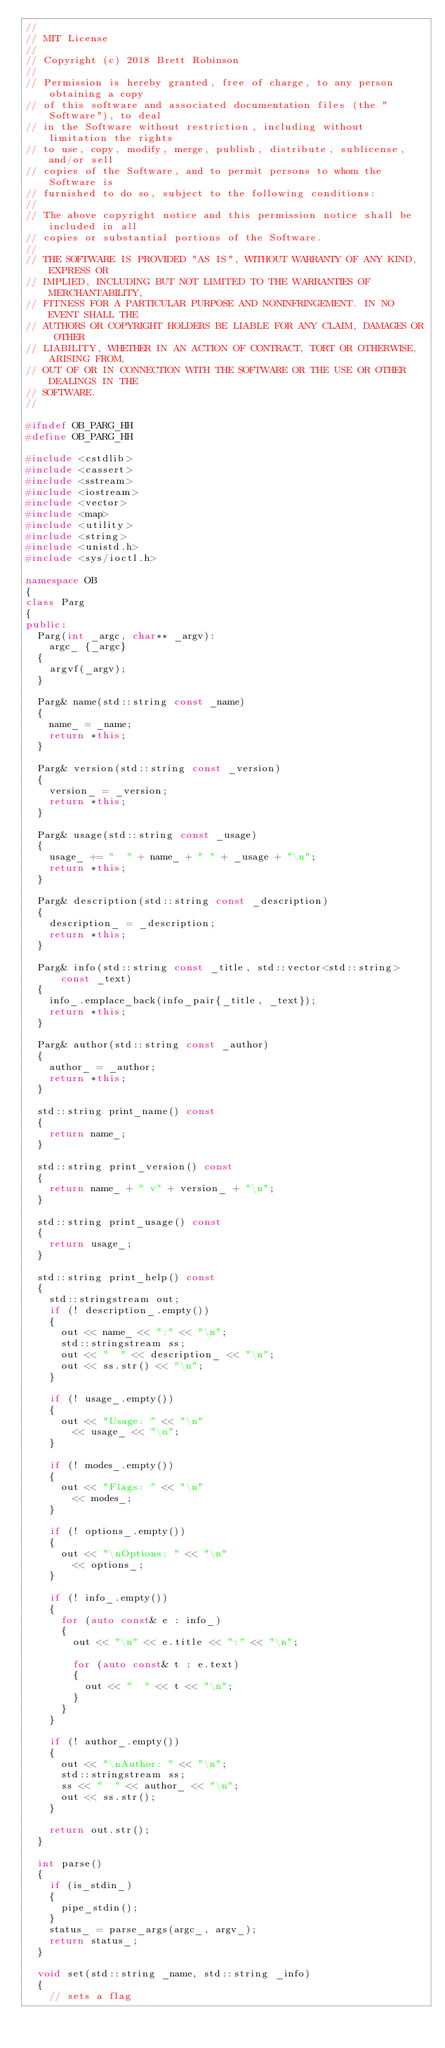<code> <loc_0><loc_0><loc_500><loc_500><_C++_>//
// MIT License
//
// Copyright (c) 2018 Brett Robinson
//
// Permission is hereby granted, free of charge, to any person obtaining a copy
// of this software and associated documentation files (the "Software"), to deal
// in the Software without restriction, including without limitation the rights
// to use, copy, modify, merge, publish, distribute, sublicense, and/or sell
// copies of the Software, and to permit persons to whom the Software is
// furnished to do so, subject to the following conditions:
//
// The above copyright notice and this permission notice shall be included in all
// copies or substantial portions of the Software.
//
// THE SOFTWARE IS PROVIDED "AS IS", WITHOUT WARRANTY OF ANY KIND, EXPRESS OR
// IMPLIED, INCLUDING BUT NOT LIMITED TO THE WARRANTIES OF MERCHANTABILITY,
// FITNESS FOR A PARTICULAR PURPOSE AND NONINFRINGEMENT. IN NO EVENT SHALL THE
// AUTHORS OR COPYRIGHT HOLDERS BE LIABLE FOR ANY CLAIM, DAMAGES OR OTHER
// LIABILITY, WHETHER IN AN ACTION OF CONTRACT, TORT OR OTHERWISE, ARISING FROM,
// OUT OF OR IN CONNECTION WITH THE SOFTWARE OR THE USE OR OTHER DEALINGS IN THE
// SOFTWARE.
//

#ifndef OB_PARG_HH
#define OB_PARG_HH

#include <cstdlib>
#include <cassert>
#include <sstream>
#include <iostream>
#include <vector>
#include <map>
#include <utility>
#include <string>
#include <unistd.h>
#include <sys/ioctl.h>

namespace OB
{
class Parg
{
public:
  Parg(int _argc, char** _argv):
    argc_ {_argc}
  {
    argvf(_argv);
  }

  Parg& name(std::string const _name)
  {
    name_ = _name;
    return *this;
  }

  Parg& version(std::string const _version)
  {
    version_ = _version;
    return *this;
  }

  Parg& usage(std::string const _usage)
  {
    usage_ += "  " + name_ + " " + _usage + "\n";
    return *this;
  }

  Parg& description(std::string const _description)
  {
    description_ = _description;
    return *this;
  }

  Parg& info(std::string const _title, std::vector<std::string> const _text)
  {
    info_.emplace_back(info_pair{_title, _text});
    return *this;
  }

  Parg& author(std::string const _author)
  {
    author_ = _author;
    return *this;
  }

  std::string print_name() const
  {
    return name_;
  }

  std::string print_version() const
  {
    return name_ + " v" + version_ + "\n";
  }

  std::string print_usage() const
  {
    return usage_;
  }

  std::string print_help() const
  {
    std::stringstream out;
    if (! description_.empty())
    {
      out << name_ << ":" << "\n";
      std::stringstream ss;
      out << "  " << description_ << "\n";
      out << ss.str() << "\n";
    }

    if (! usage_.empty())
    {
      out << "Usage: " << "\n"
        << usage_ << "\n";
    }

    if (! modes_.empty())
    {
      out << "Flags: " << "\n"
        << modes_;
    }

    if (! options_.empty())
    {
      out << "\nOptions: " << "\n"
        << options_;
    }

    if (! info_.empty())
    {
      for (auto const& e : info_)
      {
        out << "\n" << e.title << ":" << "\n";

        for (auto const& t : e.text)
        {
          out << "  " << t << "\n";
        }
      }
    }

    if (! author_.empty())
    {
      out << "\nAuthor: " << "\n";
      std::stringstream ss;
      ss << "  " << author_ << "\n";
      out << ss.str();
    }

    return out.str();
  }

  int parse()
  {
    if (is_stdin_)
    {
      pipe_stdin();
    }
    status_ = parse_args(argc_, argv_);
    return status_;
  }

  void set(std::string _name, std::string _info)
  {
    // sets a flag</code> 